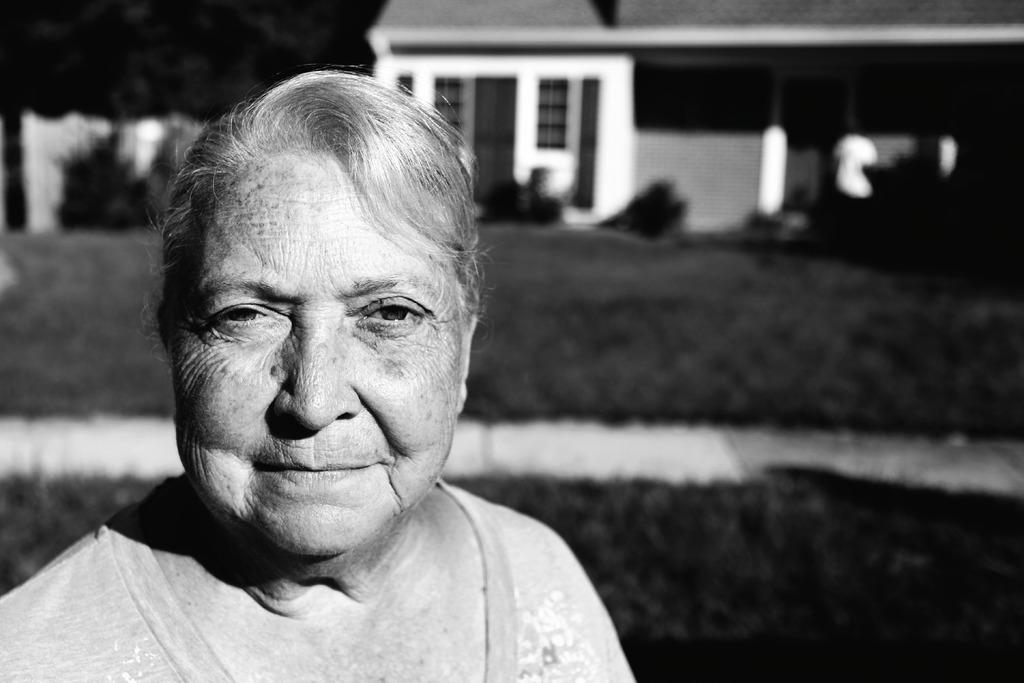Describe this image in one or two sentences. In this picture we can see a woman smiling and in the background we can see a house, trees. 